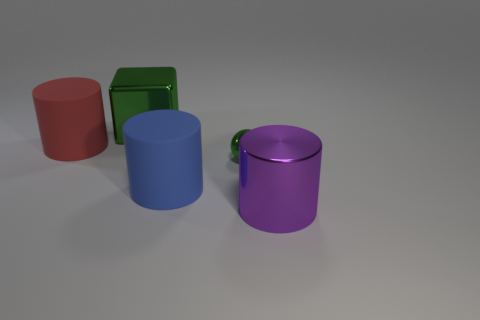Add 3 big purple metallic things. How many objects exist? 8 Subtract all cylinders. How many objects are left? 2 Subtract all spheres. Subtract all rubber objects. How many objects are left? 2 Add 5 big green things. How many big green things are left? 6 Add 4 blue things. How many blue things exist? 5 Subtract 0 cyan cylinders. How many objects are left? 5 